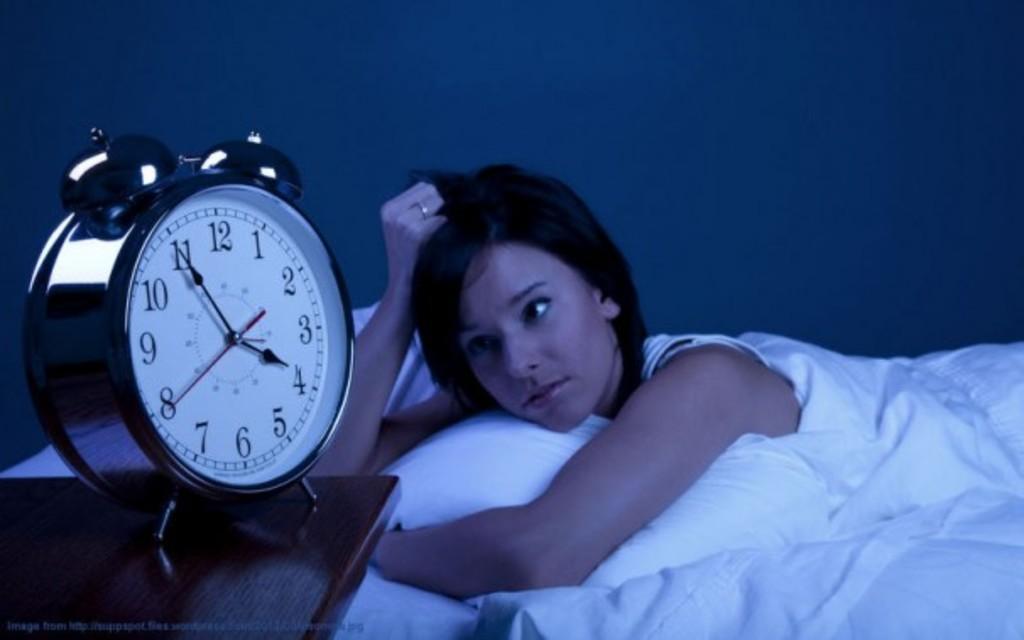Does the clock say it is 3:55?
Offer a very short reply. Yes. Time is 3.50?
Offer a very short reply. No. 